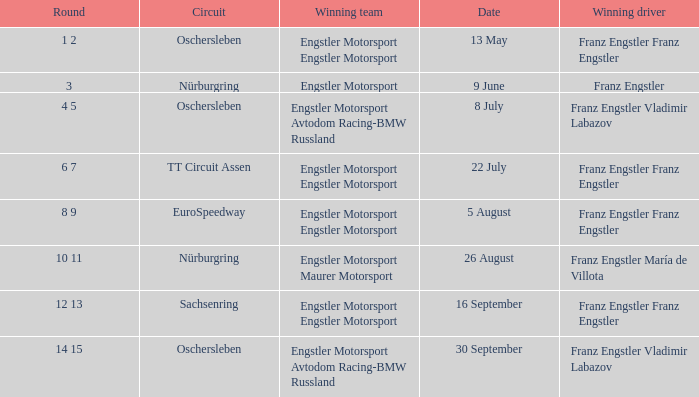Can you parse all the data within this table? {'header': ['Round', 'Circuit', 'Winning team', 'Date', 'Winning driver'], 'rows': [['1 2', 'Oschersleben', 'Engstler Motorsport Engstler Motorsport', '13 May', 'Franz Engstler Franz Engstler'], ['3', 'Nürburgring', 'Engstler Motorsport', '9 June', 'Franz Engstler'], ['4 5', 'Oschersleben', 'Engstler Motorsport Avtodom Racing-BMW Russland', '8 July', 'Franz Engstler Vladimir Labazov'], ['6 7', 'TT Circuit Assen', 'Engstler Motorsport Engstler Motorsport', '22 July', 'Franz Engstler Franz Engstler'], ['8 9', 'EuroSpeedway', 'Engstler Motorsport Engstler Motorsport', '5 August', 'Franz Engstler Franz Engstler'], ['10 11', 'Nürburgring', 'Engstler Motorsport Maurer Motorsport', '26 August', 'Franz Engstler María de Villota'], ['12 13', 'Sachsenring', 'Engstler Motorsport Engstler Motorsport', '16 September', 'Franz Engstler Franz Engstler'], ['14 15', 'Oschersleben', 'Engstler Motorsport Avtodom Racing-BMW Russland', '30 September', 'Franz Engstler Vladimir Labazov']]} Who is the Winning Driver that has a Winning team of Engstler Motorsport Engstler Motorsport and also the Date 22 July? Franz Engstler Franz Engstler. 